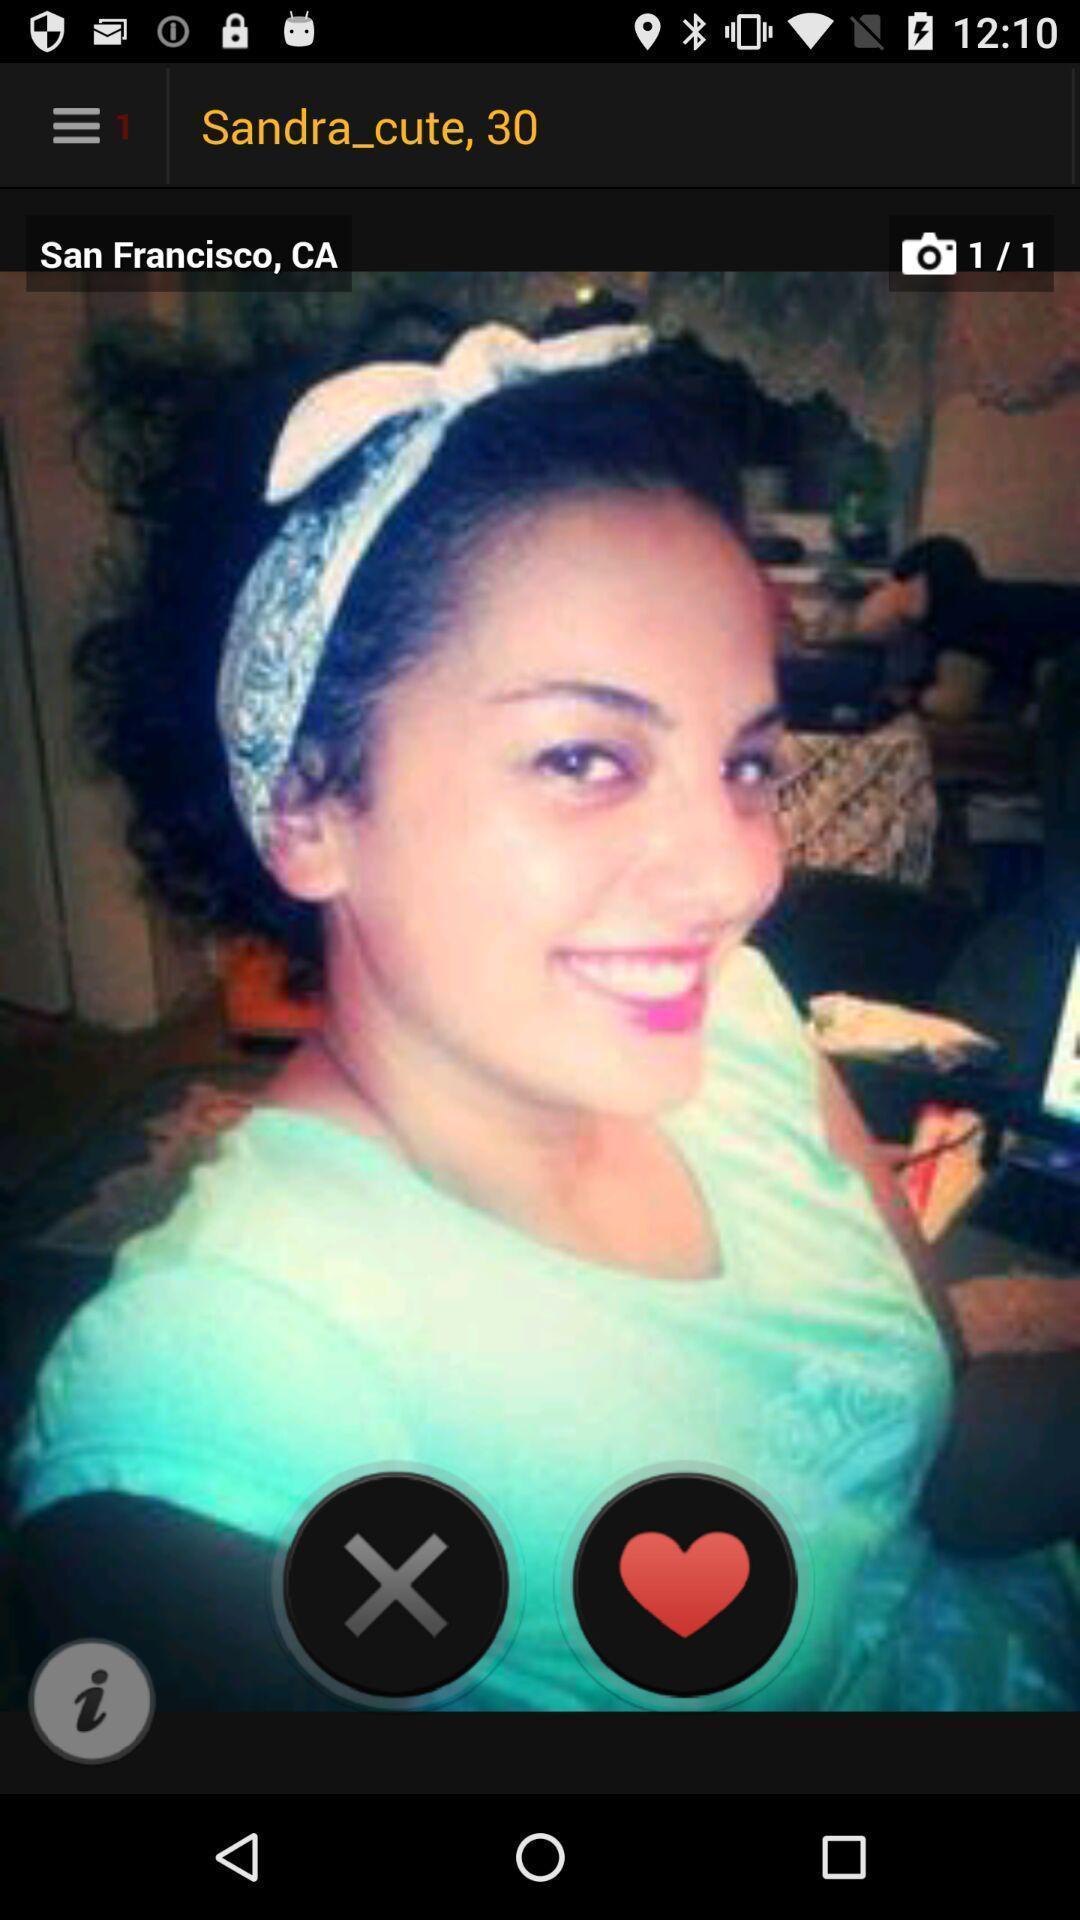Explain what's happening in this screen capture. Screen displaying the image of a women. 